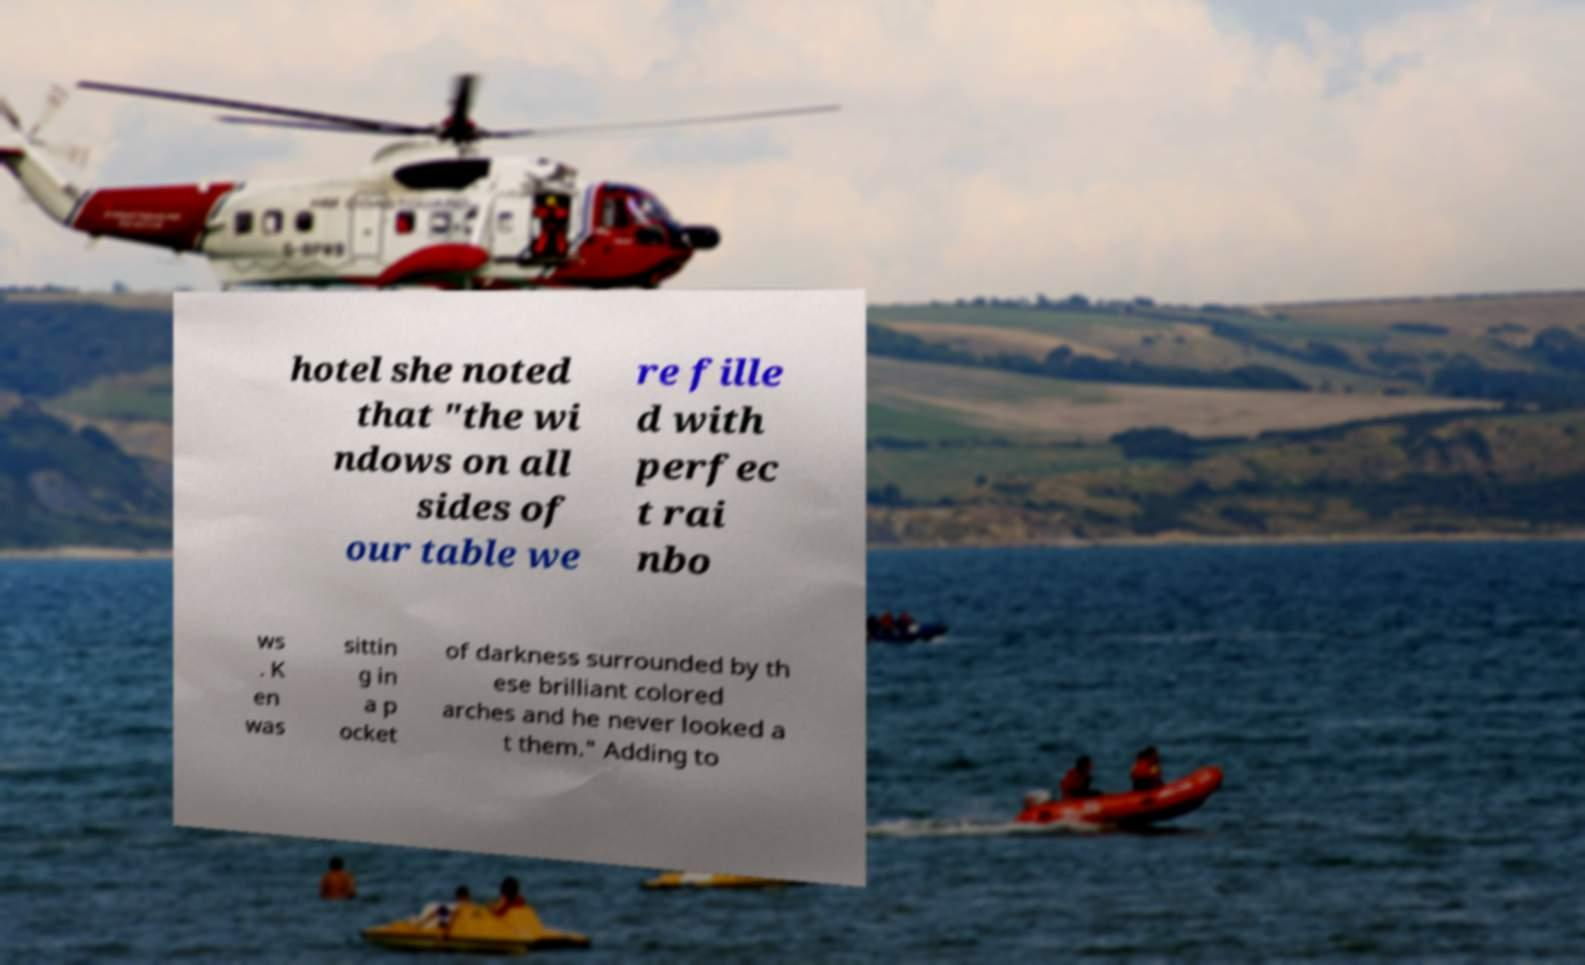What messages or text are displayed in this image? I need them in a readable, typed format. hotel she noted that "the wi ndows on all sides of our table we re fille d with perfec t rai nbo ws . K en was sittin g in a p ocket of darkness surrounded by th ese brilliant colored arches and he never looked a t them." Adding to 